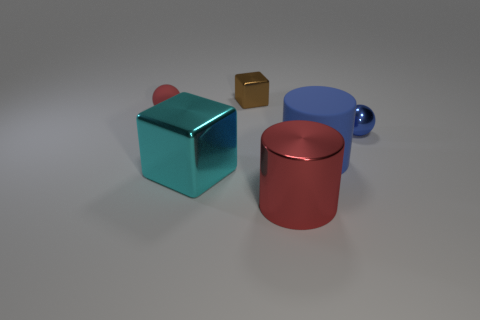There is a cyan thing that is the same material as the blue sphere; what is its shape?
Offer a terse response. Cube. There is a tiny thing that is both left of the small shiny ball and on the right side of the big cyan object; what is its color?
Your response must be concise. Brown. There is a red object that is right of the red thing that is behind the cyan block; how big is it?
Ensure brevity in your answer.  Large. Are there any rubber things that have the same color as the shiny sphere?
Your answer should be very brief. Yes. Is the number of tiny red things to the right of the small red rubber ball the same as the number of tiny cyan rubber cubes?
Offer a very short reply. Yes. What number of gray rubber balls are there?
Your answer should be very brief. 0. What shape is the thing that is both to the left of the tiny metal cube and behind the rubber cylinder?
Provide a short and direct response. Sphere. There is a rubber thing that is in front of the blue ball; does it have the same color as the small thing in front of the small matte thing?
Give a very brief answer. Yes. What size is the metal sphere that is the same color as the big rubber thing?
Make the answer very short. Small. Are there any objects made of the same material as the big cyan cube?
Offer a terse response. Yes. 